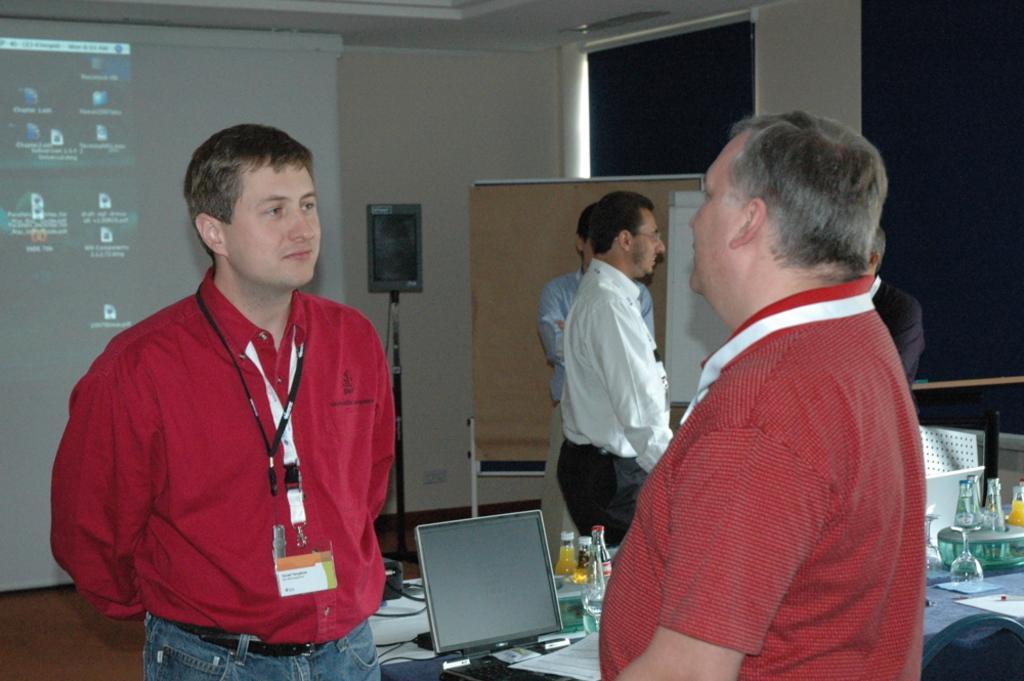Please provide a concise description of this image. In this image we can see a few people, there is a table, on that there are bottles, papers, glass, a laptop, also we can see some other objects, there is a screen with pictures, and text on it, also we can see the wall, and some papers on the board. 